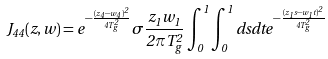Convert formula to latex. <formula><loc_0><loc_0><loc_500><loc_500>J _ { 4 4 } ( z , w ) = e ^ { - \frac { ( z _ { 4 } - w _ { 4 } ) ^ { 2 } } { 4 T _ { g } ^ { 2 } } } \sigma \frac { z _ { 1 } w _ { 1 } } { 2 \pi T _ { g } ^ { 2 } } \int _ { 0 } ^ { 1 } \int _ { 0 } ^ { 1 } d s d t e ^ { - \frac { ( z _ { 1 } s - w _ { 1 } t ) ^ { 2 } } { 4 T _ { g } ^ { 2 } } }</formula> 